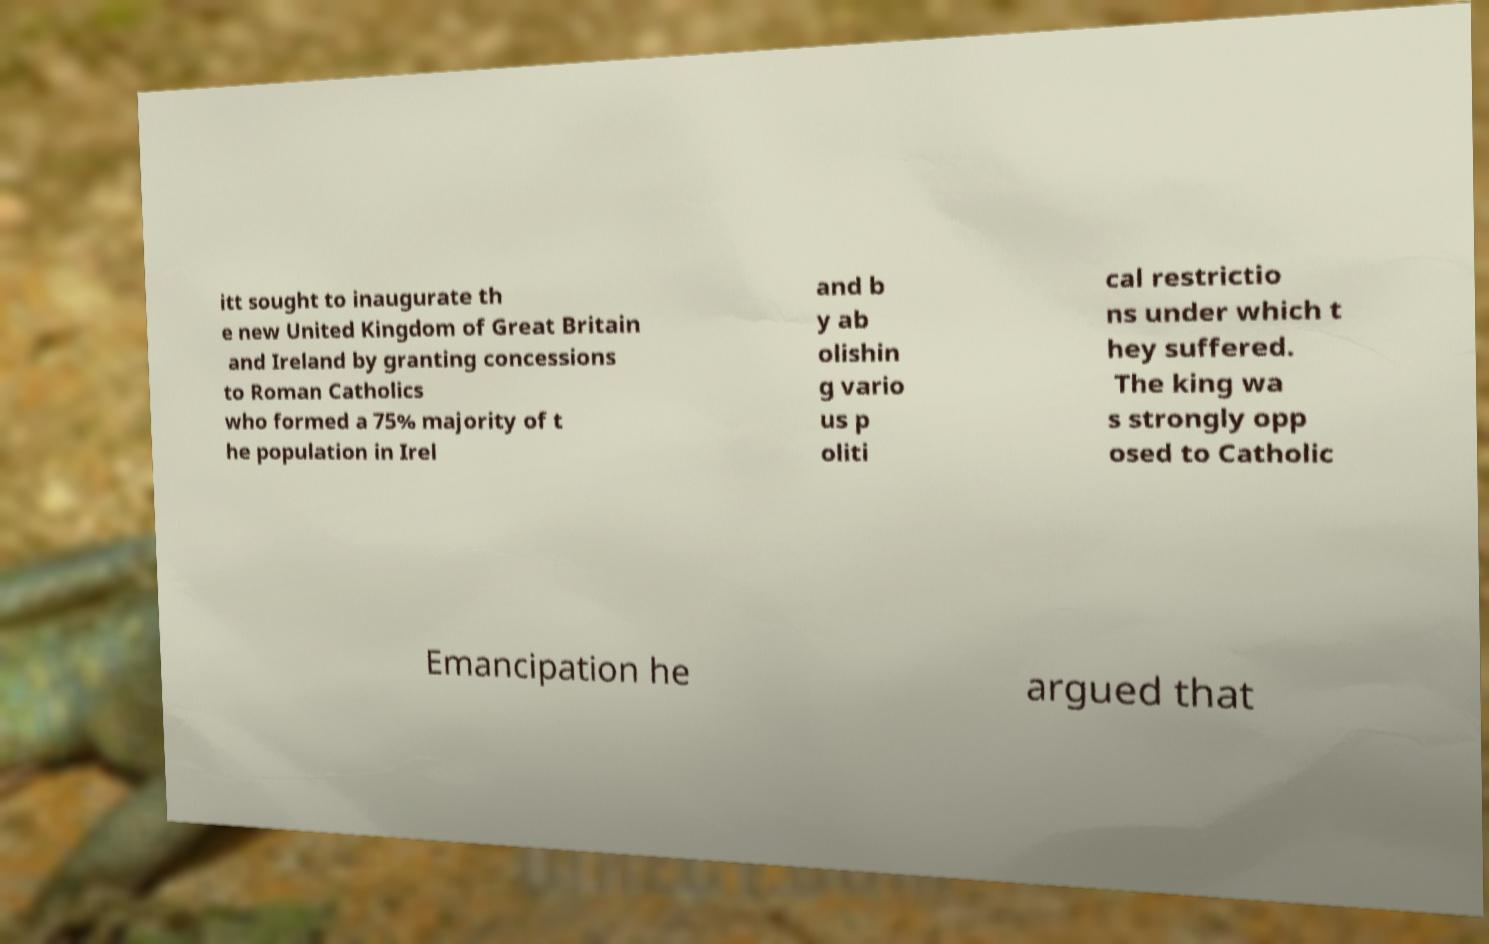Could you extract and type out the text from this image? itt sought to inaugurate th e new United Kingdom of Great Britain and Ireland by granting concessions to Roman Catholics who formed a 75% majority of t he population in Irel and b y ab olishin g vario us p oliti cal restrictio ns under which t hey suffered. The king wa s strongly opp osed to Catholic Emancipation he argued that 